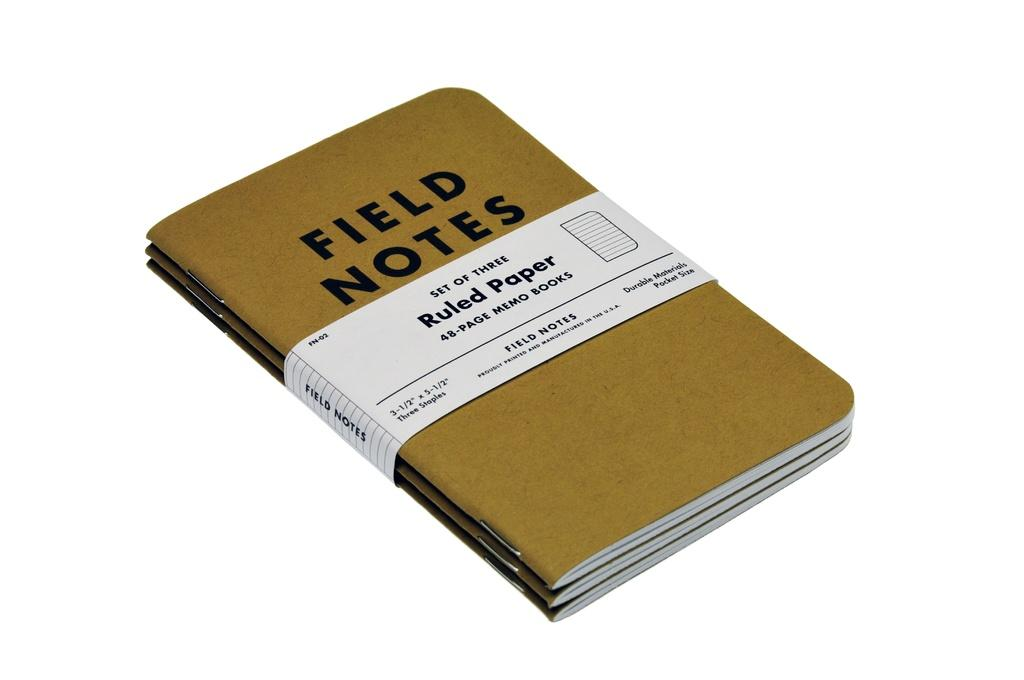<image>
Relay a brief, clear account of the picture shown. a stack of notebooks with the words 'field notes' on the top 